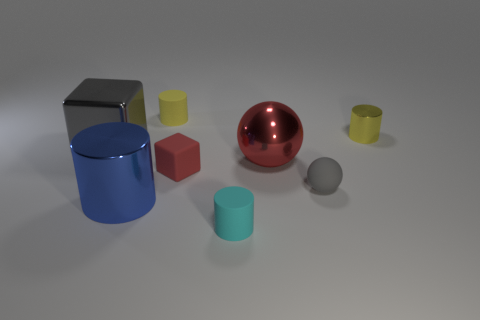Is the material of the large gray object the same as the small cylinder right of the rubber sphere?
Offer a very short reply. Yes. Is there a metal cylinder of the same size as the gray matte object?
Offer a very short reply. Yes. Are there an equal number of small red things in front of the red matte thing and tiny purple shiny spheres?
Keep it short and to the point. Yes. What size is the red block?
Make the answer very short. Small. There is a gray sphere that is in front of the tiny red cube; how many small metallic things are behind it?
Your response must be concise. 1. What shape is the tiny thing that is both on the left side of the big shiny ball and behind the red metal ball?
Your answer should be very brief. Cylinder. How many big cylinders are the same color as the shiny block?
Provide a succinct answer. 0. Are there any large metallic cylinders that are in front of the small yellow thing in front of the rubber cylinder that is behind the small cyan matte cylinder?
Offer a terse response. Yes. There is a cylinder that is both behind the cyan object and in front of the small red cube; how big is it?
Your answer should be compact. Large. How many red objects have the same material as the large blue thing?
Ensure brevity in your answer.  1. 